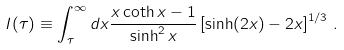<formula> <loc_0><loc_0><loc_500><loc_500>I ( \tau ) \equiv \int _ { \tau } ^ { \infty } d x \frac { x \coth x - 1 } { \sinh ^ { 2 } x } \left [ \sinh ( 2 x ) - 2 x \right ] ^ { 1 / 3 } \, .</formula> 